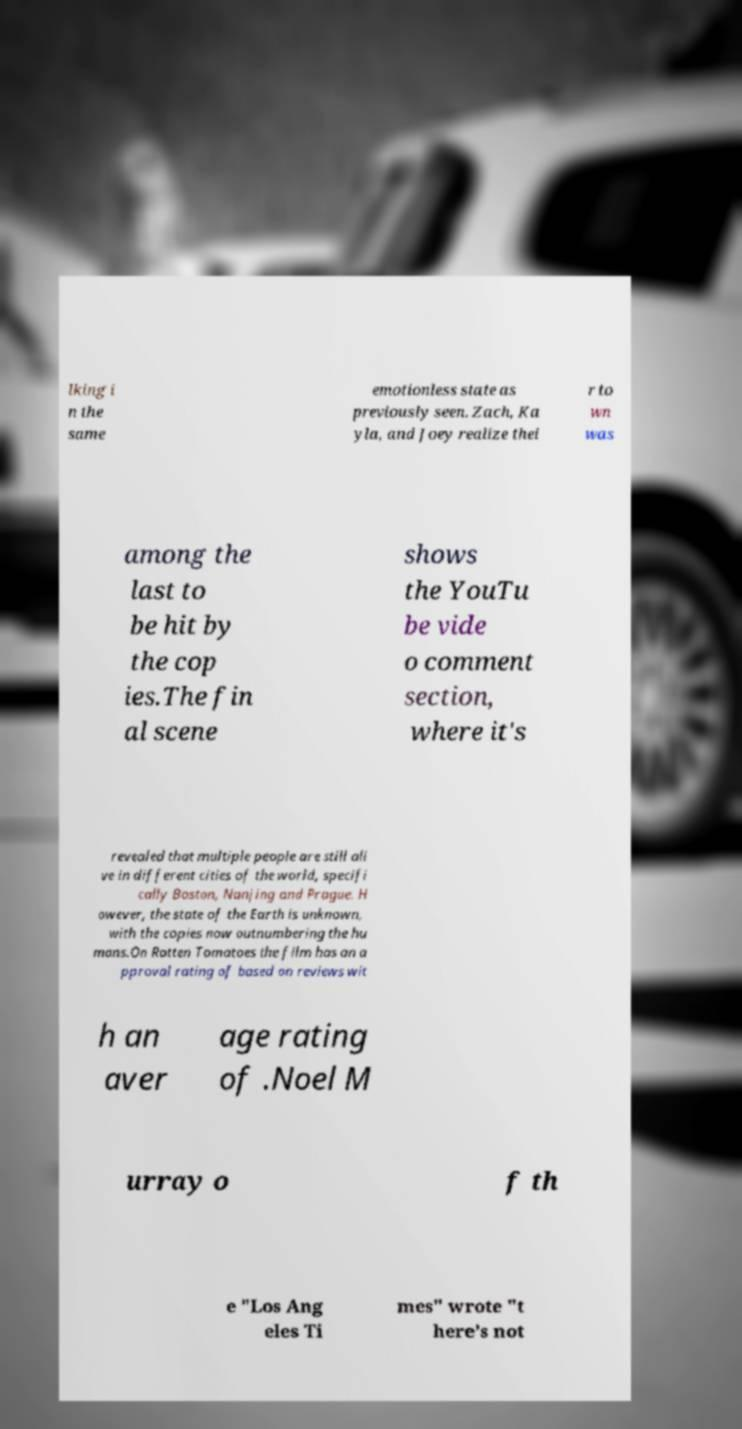What messages or text are displayed in this image? I need them in a readable, typed format. lking i n the same emotionless state as previously seen. Zach, Ka yla, and Joey realize thei r to wn was among the last to be hit by the cop ies.The fin al scene shows the YouTu be vide o comment section, where it's revealed that multiple people are still ali ve in different cities of the world, specifi cally Boston, Nanjing and Prague. H owever, the state of the Earth is unknown, with the copies now outnumbering the hu mans.On Rotten Tomatoes the film has an a pproval rating of based on reviews wit h an aver age rating of .Noel M urray o f th e "Los Ang eles Ti mes" wrote "t here’s not 